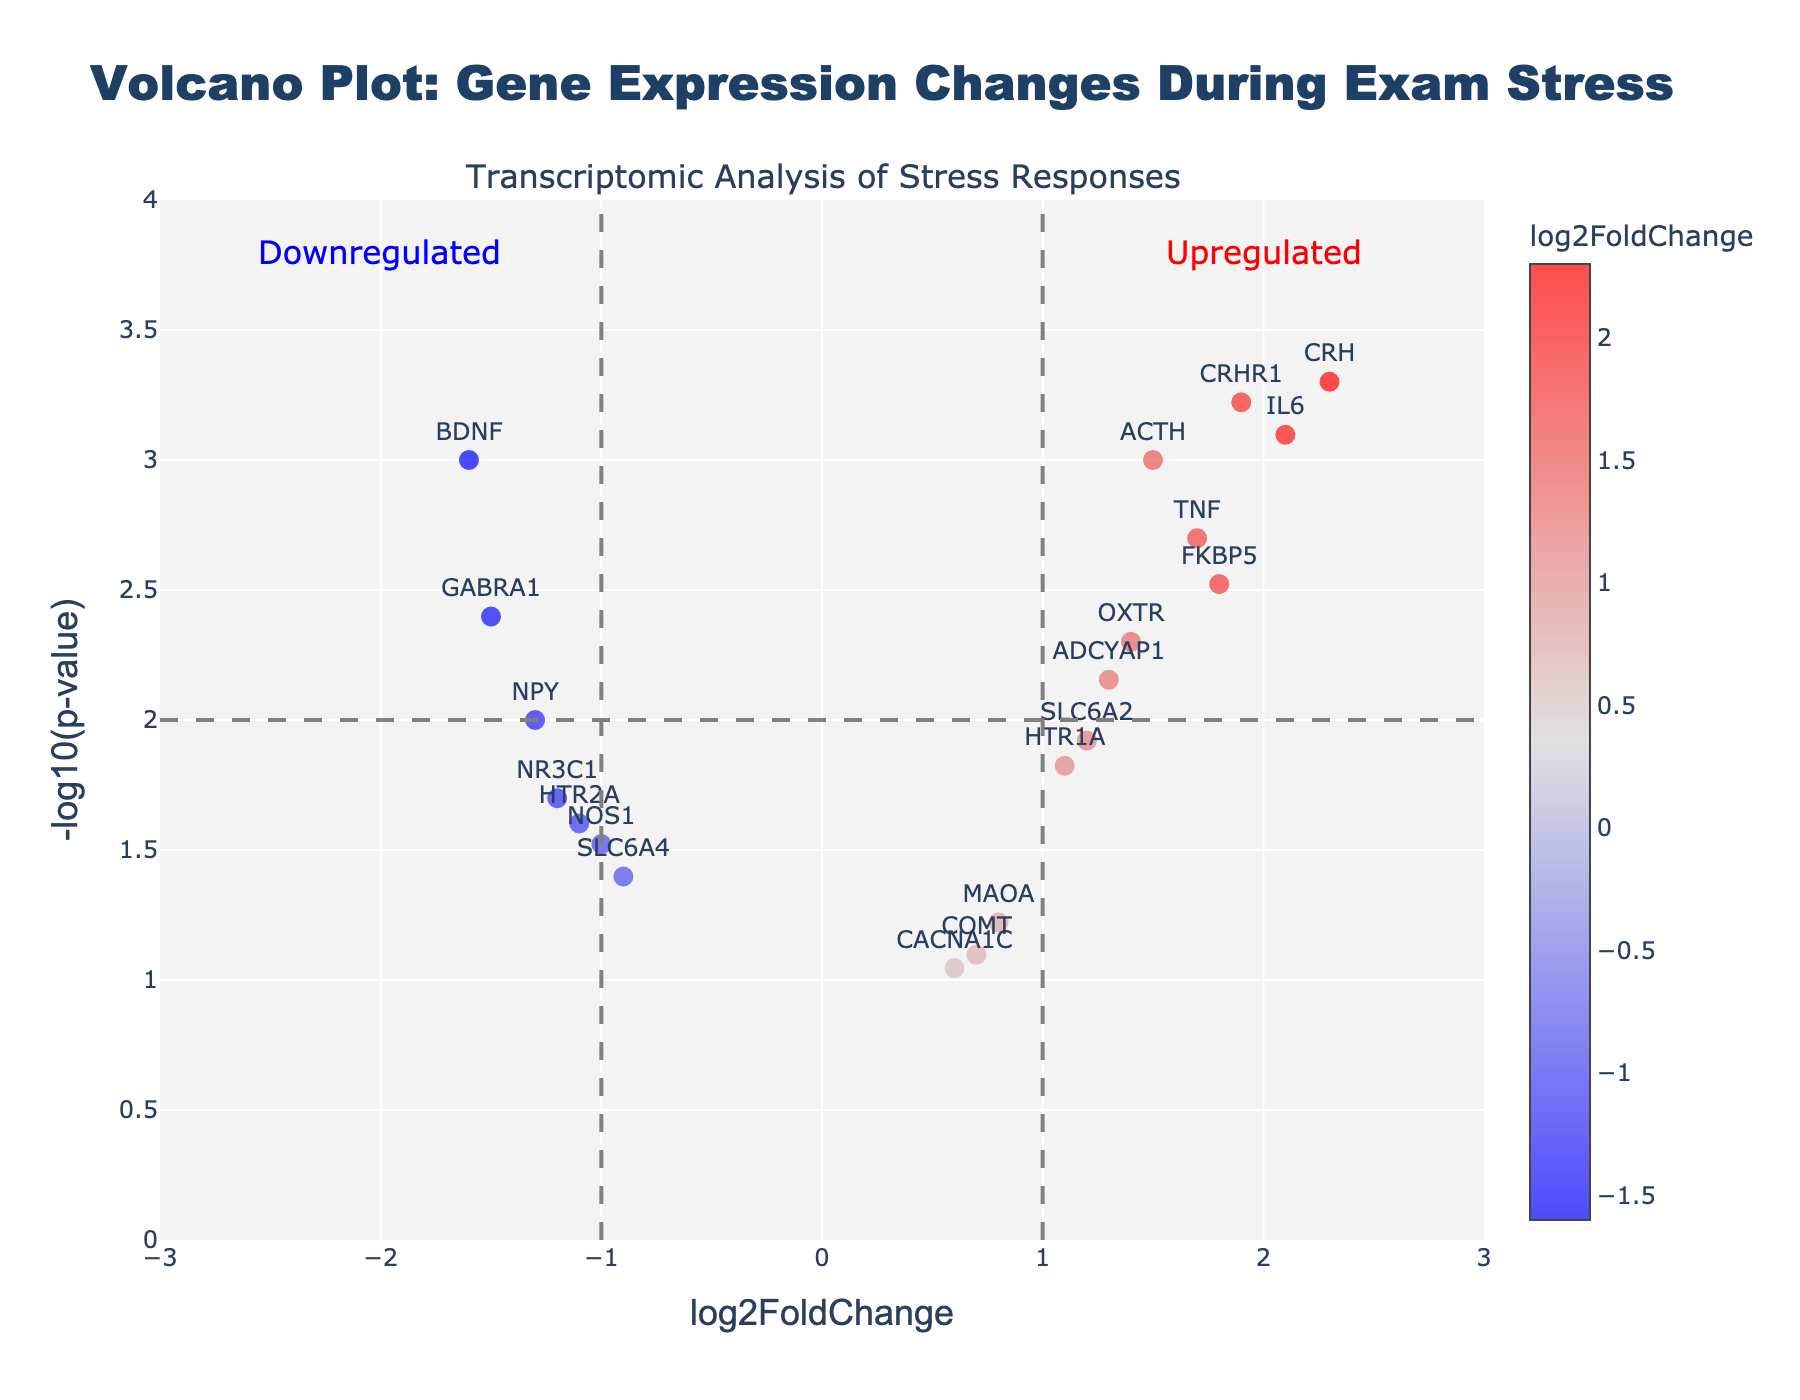What is the title of the plot? The title is usually located at the top of the plot and provides an overview of what is being illustrated. In this case, it indicates the topic of the analysis.
Answer: Volcano Plot: Gene Expression Changes During Exam Stress How many genes are shown on the plot? Each data point on the plot represents a gene. You can count the number of points to get the total number of genes.
Answer: 19 Which gene has the highest log2FoldChange? Look at the x-axis (log2FoldChange) and find the gene farthest to the right.
Answer: CRH What is the log2FoldChange value of gene BDNF? Locate the gene BDNF on the plot and check its position on the x-axis.
Answer: -1.6 Are there more upregulated or downregulated genes? Upregulated genes have positive log2FoldChange values and are on the right side of the plot. Downregulated genes have negative values and are on the left side. Count the number of points on each side to compare.
Answer: More upregulated Which gene has the most significant p-value? The significance of the p-value is represented by -log10(p-value) on the y-axis. The higher the y-value, the more significant the p-value. Find the gene with the highest y-value.
Answer: CRH What range of log2FoldChange values is shown on the x-axis? Look at the labels on the x-axis to determine the range.
Answer: -3 to 3 Are there any genes that are both significantly upregulated and have a log2FoldChange greater than 1? Find genes with high positions on the y-axis (indicating significance) and then check if their x-axis (log2FoldChange) values are greater than 1.
Answer: Yes, CRH, IL6, and CRHR1 Which genes are downregulated and have a log2FoldChange less than -1? Check for genes with log2FoldChange values less than -1 on the x-axis.
Answer: NR3C1, BDNF, GABRA1, and NPY What is the threshold line for significance on the y-axis? Check where the horizontal dashed line is placed on the y-axis, which typically indicates the threshold for statistical significance.
Answer: 2 